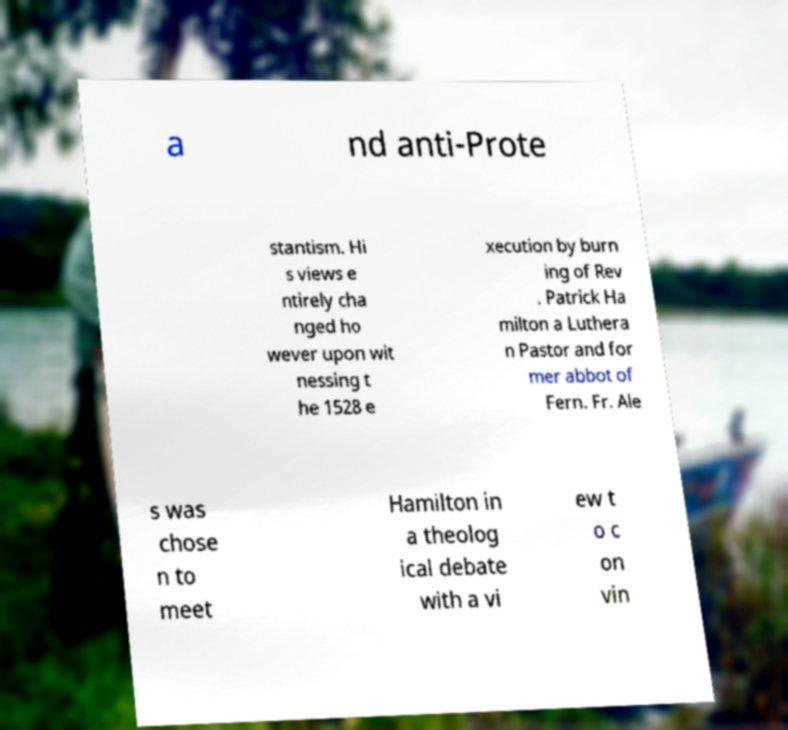Please identify and transcribe the text found in this image. a nd anti-Prote stantism. Hi s views e ntirely cha nged ho wever upon wit nessing t he 1528 e xecution by burn ing of Rev . Patrick Ha milton a Luthera n Pastor and for mer abbot of Fern. Fr. Ale s was chose n to meet Hamilton in a theolog ical debate with a vi ew t o c on vin 